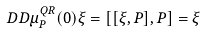<formula> <loc_0><loc_0><loc_500><loc_500>\ D D \mu _ { P } ^ { Q R } ( 0 ) \xi = [ [ \xi , P ] , P ] = \xi</formula> 